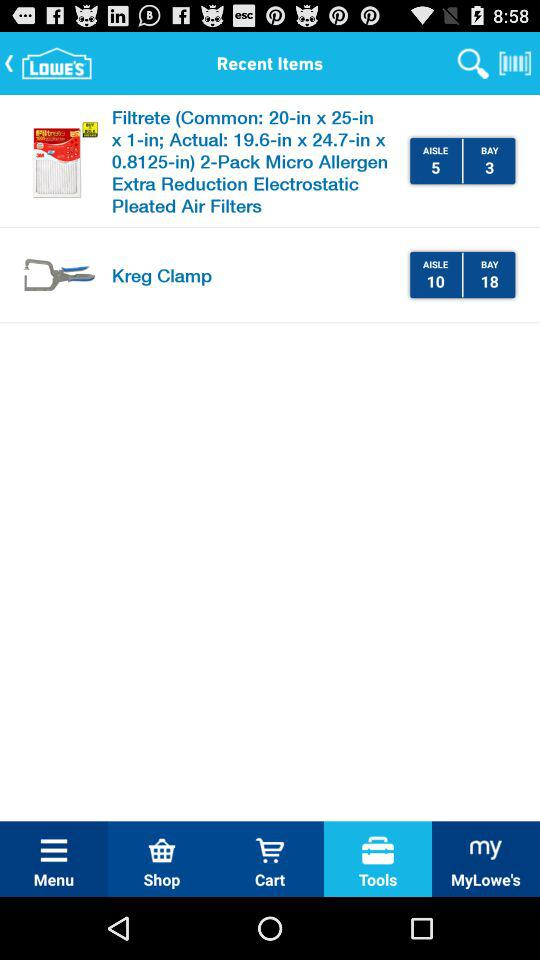How many items have a bay number?
Answer the question using a single word or phrase. 2 